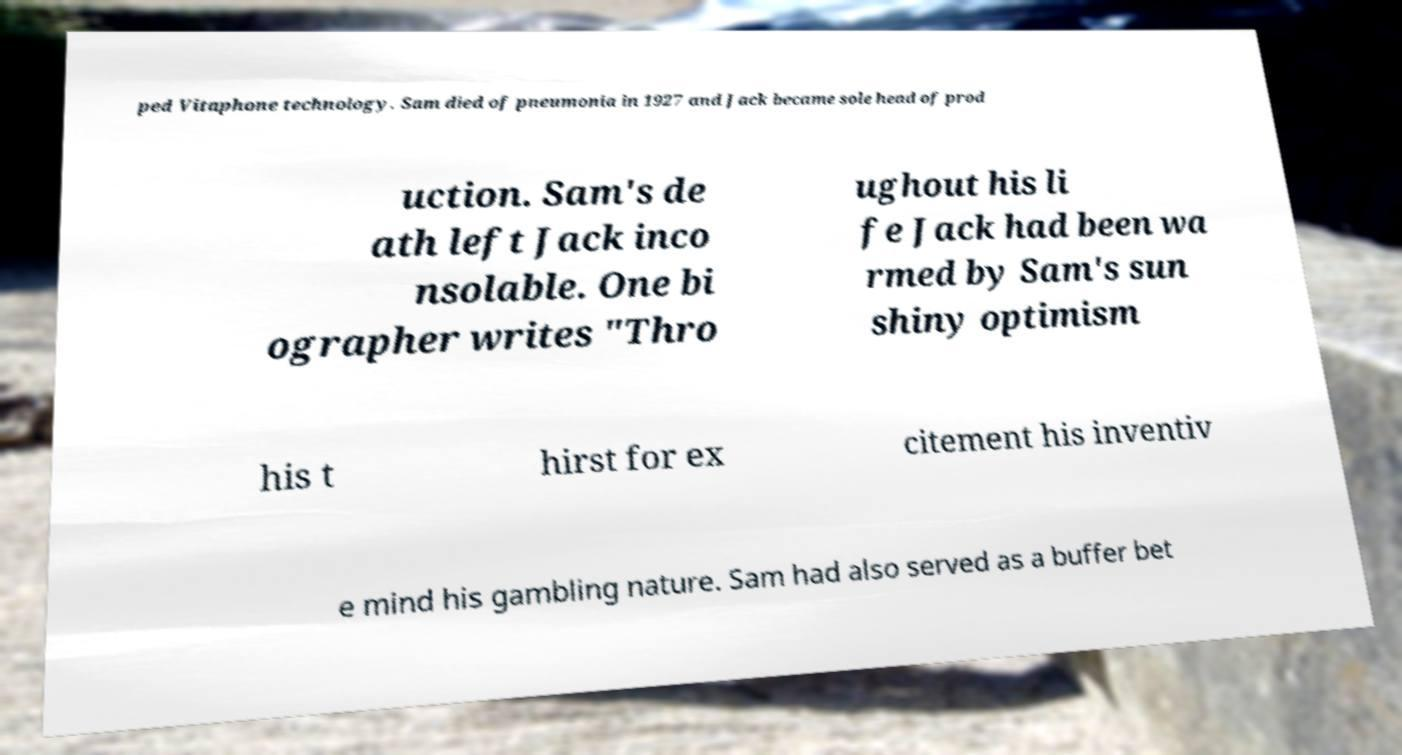I need the written content from this picture converted into text. Can you do that? ped Vitaphone technology. Sam died of pneumonia in 1927 and Jack became sole head of prod uction. Sam's de ath left Jack inco nsolable. One bi ographer writes "Thro ughout his li fe Jack had been wa rmed by Sam's sun shiny optimism his t hirst for ex citement his inventiv e mind his gambling nature. Sam had also served as a buffer bet 